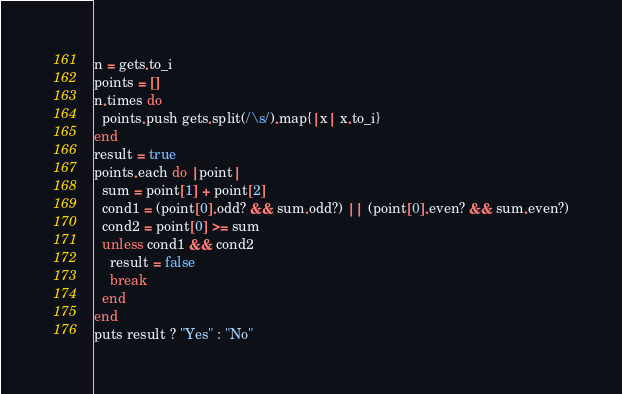Convert code to text. <code><loc_0><loc_0><loc_500><loc_500><_Ruby_>n = gets.to_i
points = []
n.times do
  points.push gets.split(/\s/).map{|x| x.to_i}
end
result = true
points.each do |point|
  sum = point[1] + point[2]
  cond1 = (point[0].odd? && sum.odd?) || (point[0].even? && sum.even?)
  cond2 = point[0] >= sum
  unless cond1 && cond2
    result = false
    break
  end
end
puts result ? "Yes" : "No"</code> 